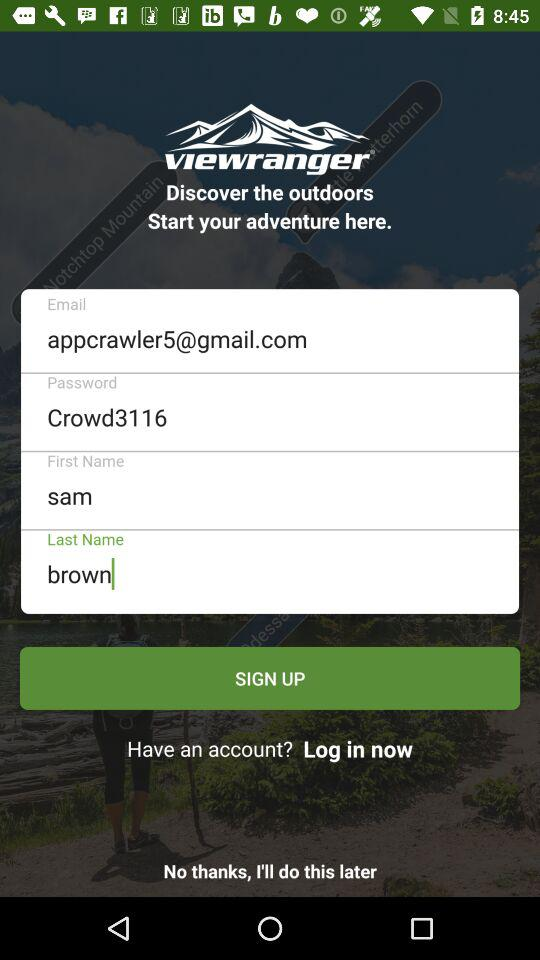What is the last name? The last name is Brown. 